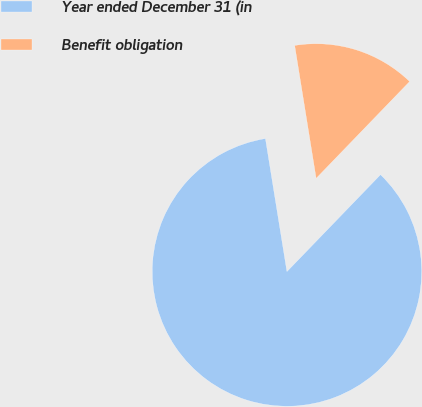Convert chart. <chart><loc_0><loc_0><loc_500><loc_500><pie_chart><fcel>Year ended December 31 (in<fcel>Benefit obligation<nl><fcel>85.23%<fcel>14.77%<nl></chart> 